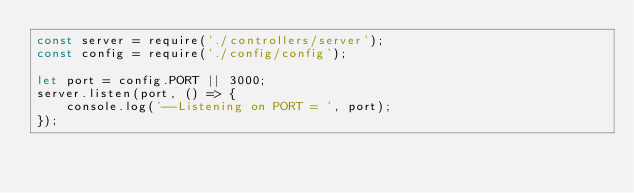<code> <loc_0><loc_0><loc_500><loc_500><_JavaScript_>const server = require('./controllers/server');
const config = require('./config/config');

let port = config.PORT || 3000;
server.listen(port, () => {
    console.log('--Listening on PORT = ', port);
});</code> 